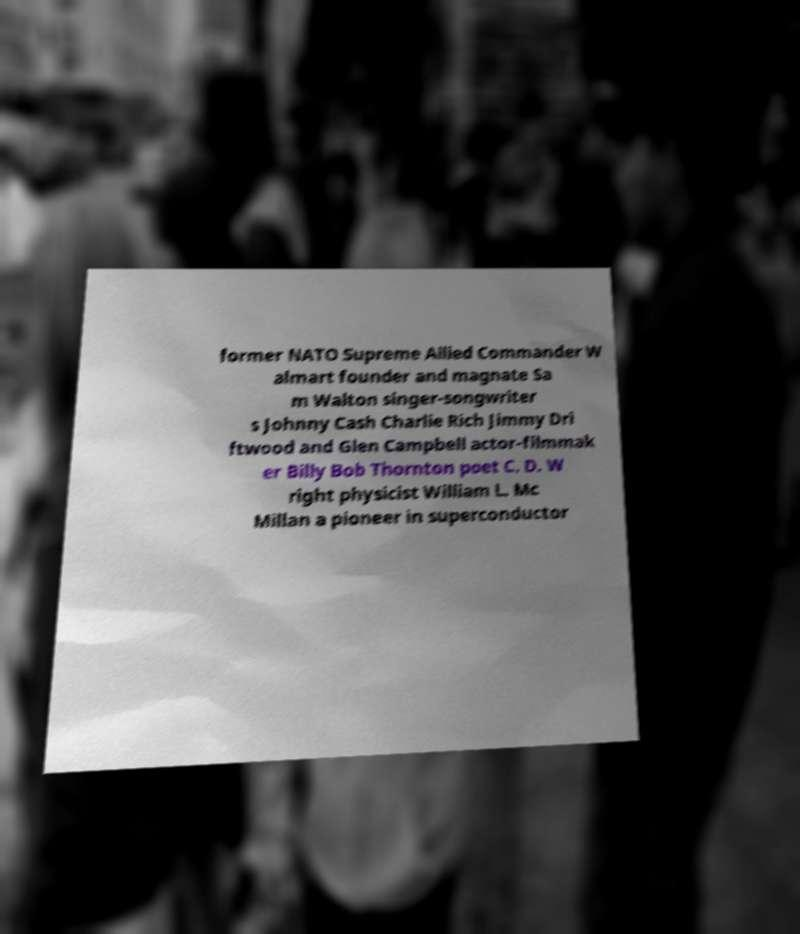I need the written content from this picture converted into text. Can you do that? former NATO Supreme Allied Commander W almart founder and magnate Sa m Walton singer-songwriter s Johnny Cash Charlie Rich Jimmy Dri ftwood and Glen Campbell actor-filmmak er Billy Bob Thornton poet C. D. W right physicist William L. Mc Millan a pioneer in superconductor 